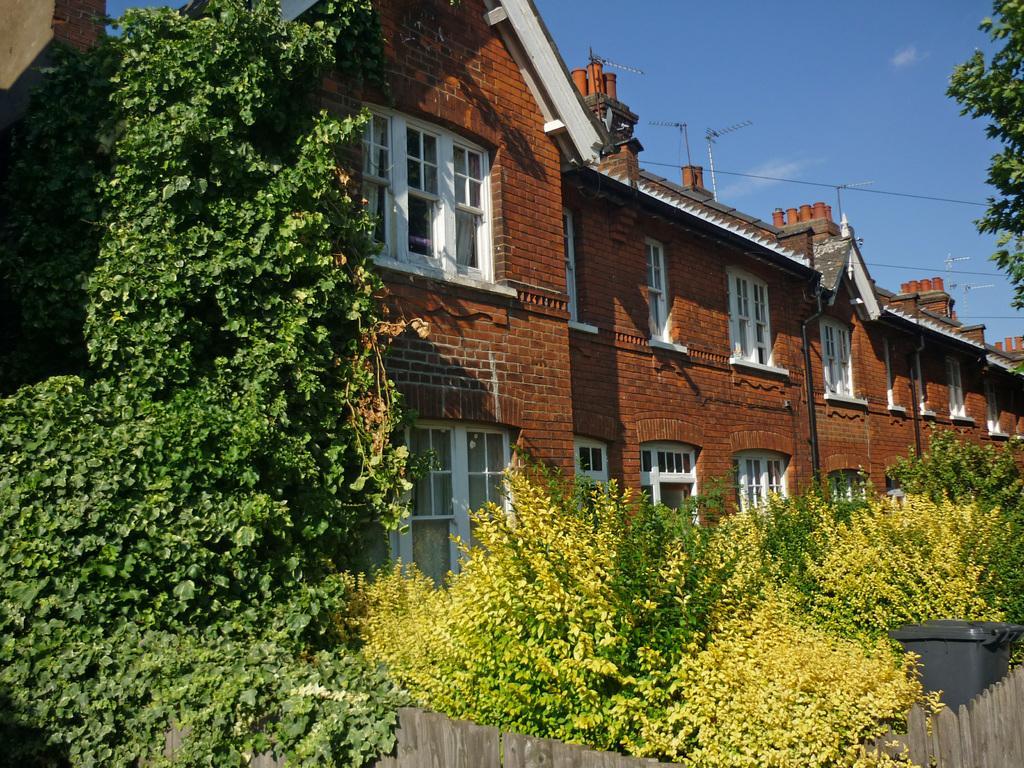Can you describe this image briefly? In this picture we can see a fence around some plants and dustbin. We can see green plants on the left side and on the right side. There is a building. We can see a few windows and antennas on this building. Sky is blue in color. 